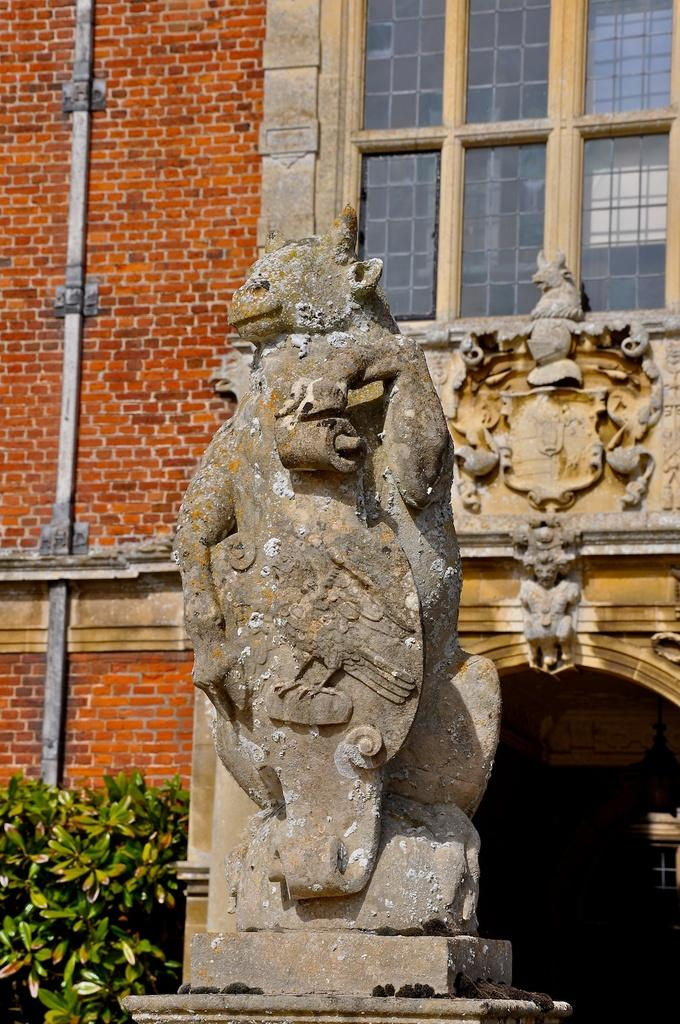What is the main subject in the image? There is a sculpture in the image. What type of structure can be seen in the background? There is a brick wall in the image. Is there any opening in the brick wall? Yes, there is a window in the image. What can be seen outside the window? Leaves are visible in the image. What architectural feature is present in the brick wall? There is an arch in the image. How does the sculpture compare to the church in the image? There is no church present in the image, so a comparison cannot be made. 